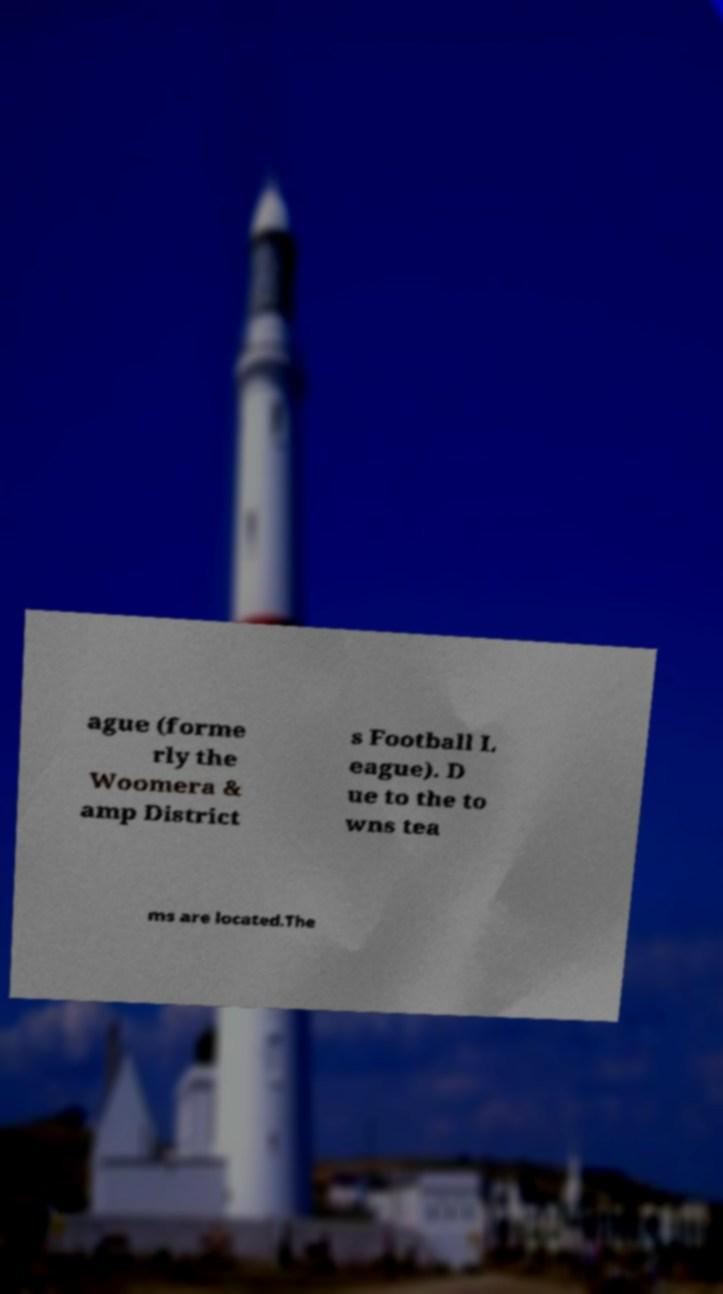Please read and relay the text visible in this image. What does it say? ague (forme rly the Woomera & amp District s Football L eague). D ue to the to wns tea ms are located.The 